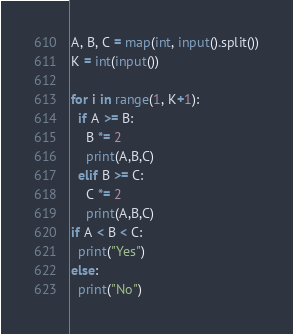<code> <loc_0><loc_0><loc_500><loc_500><_Python_>A, B, C = map(int, input().split())
K = int(input())

for i in range(1, K+1):
  if A >= B:
    B *= 2
    print(A,B,C)
  elif B >= C:
    C *= 2
    print(A,B,C)
if A < B < C:
  print("Yes")
else:
  print("No")</code> 